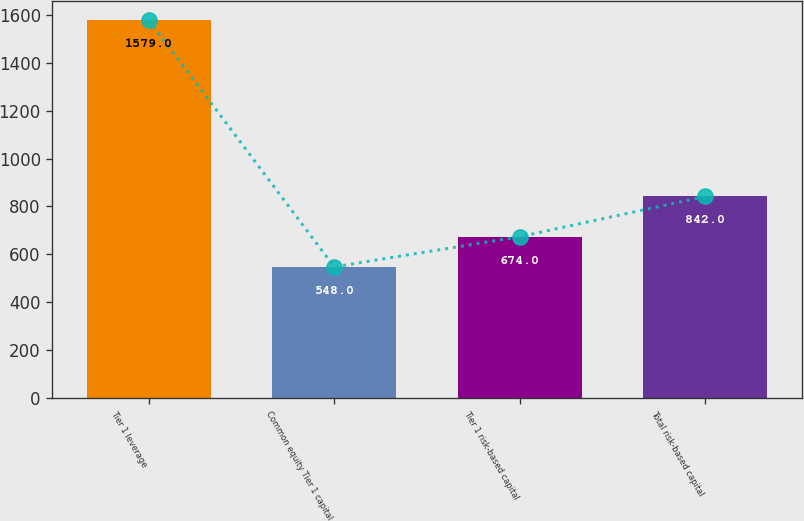Convert chart to OTSL. <chart><loc_0><loc_0><loc_500><loc_500><bar_chart><fcel>Tier 1 leverage<fcel>Common equity Tier 1 capital<fcel>Tier 1 risk-based capital<fcel>Total risk-based capital<nl><fcel>1579<fcel>548<fcel>674<fcel>842<nl></chart> 